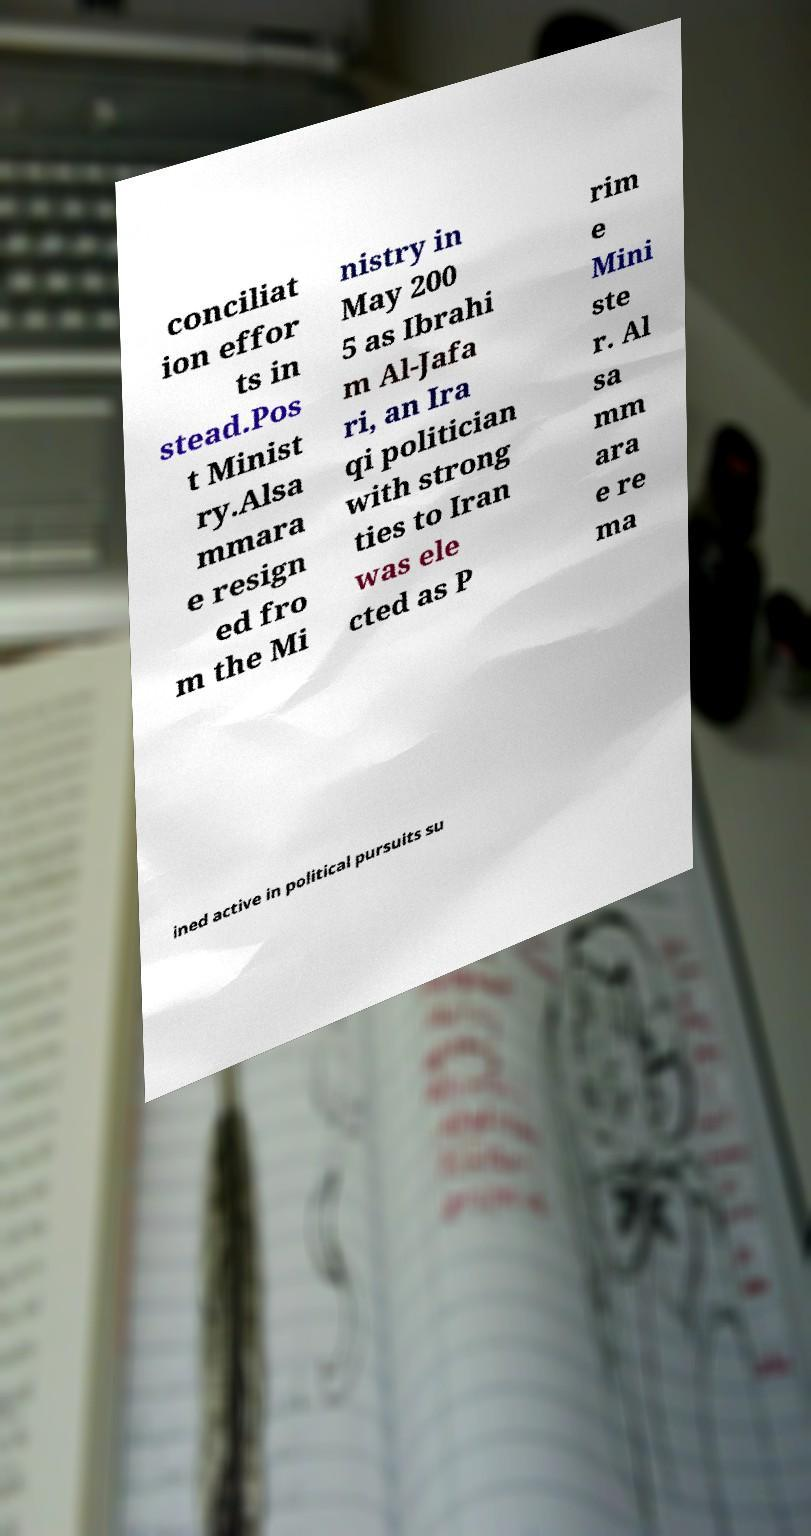Can you read and provide the text displayed in the image?This photo seems to have some interesting text. Can you extract and type it out for me? conciliat ion effor ts in stead.Pos t Minist ry.Alsa mmara e resign ed fro m the Mi nistry in May 200 5 as Ibrahi m Al-Jafa ri, an Ira qi politician with strong ties to Iran was ele cted as P rim e Mini ste r. Al sa mm ara e re ma ined active in political pursuits su 